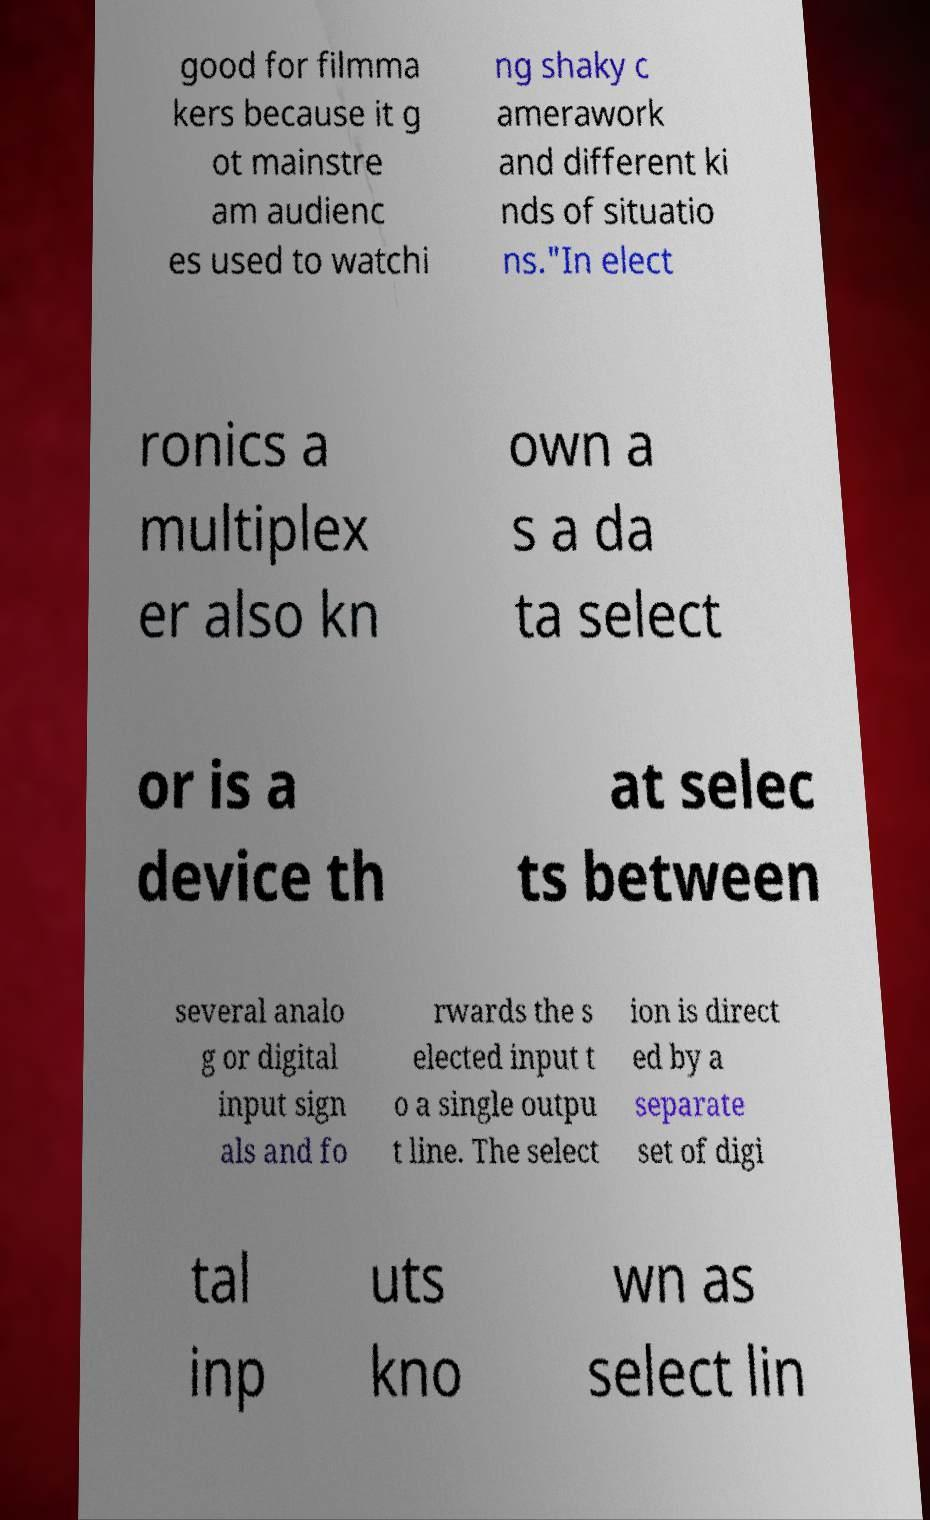Could you assist in decoding the text presented in this image and type it out clearly? good for filmma kers because it g ot mainstre am audienc es used to watchi ng shaky c amerawork and different ki nds of situatio ns."In elect ronics a multiplex er also kn own a s a da ta select or is a device th at selec ts between several analo g or digital input sign als and fo rwards the s elected input t o a single outpu t line. The select ion is direct ed by a separate set of digi tal inp uts kno wn as select lin 